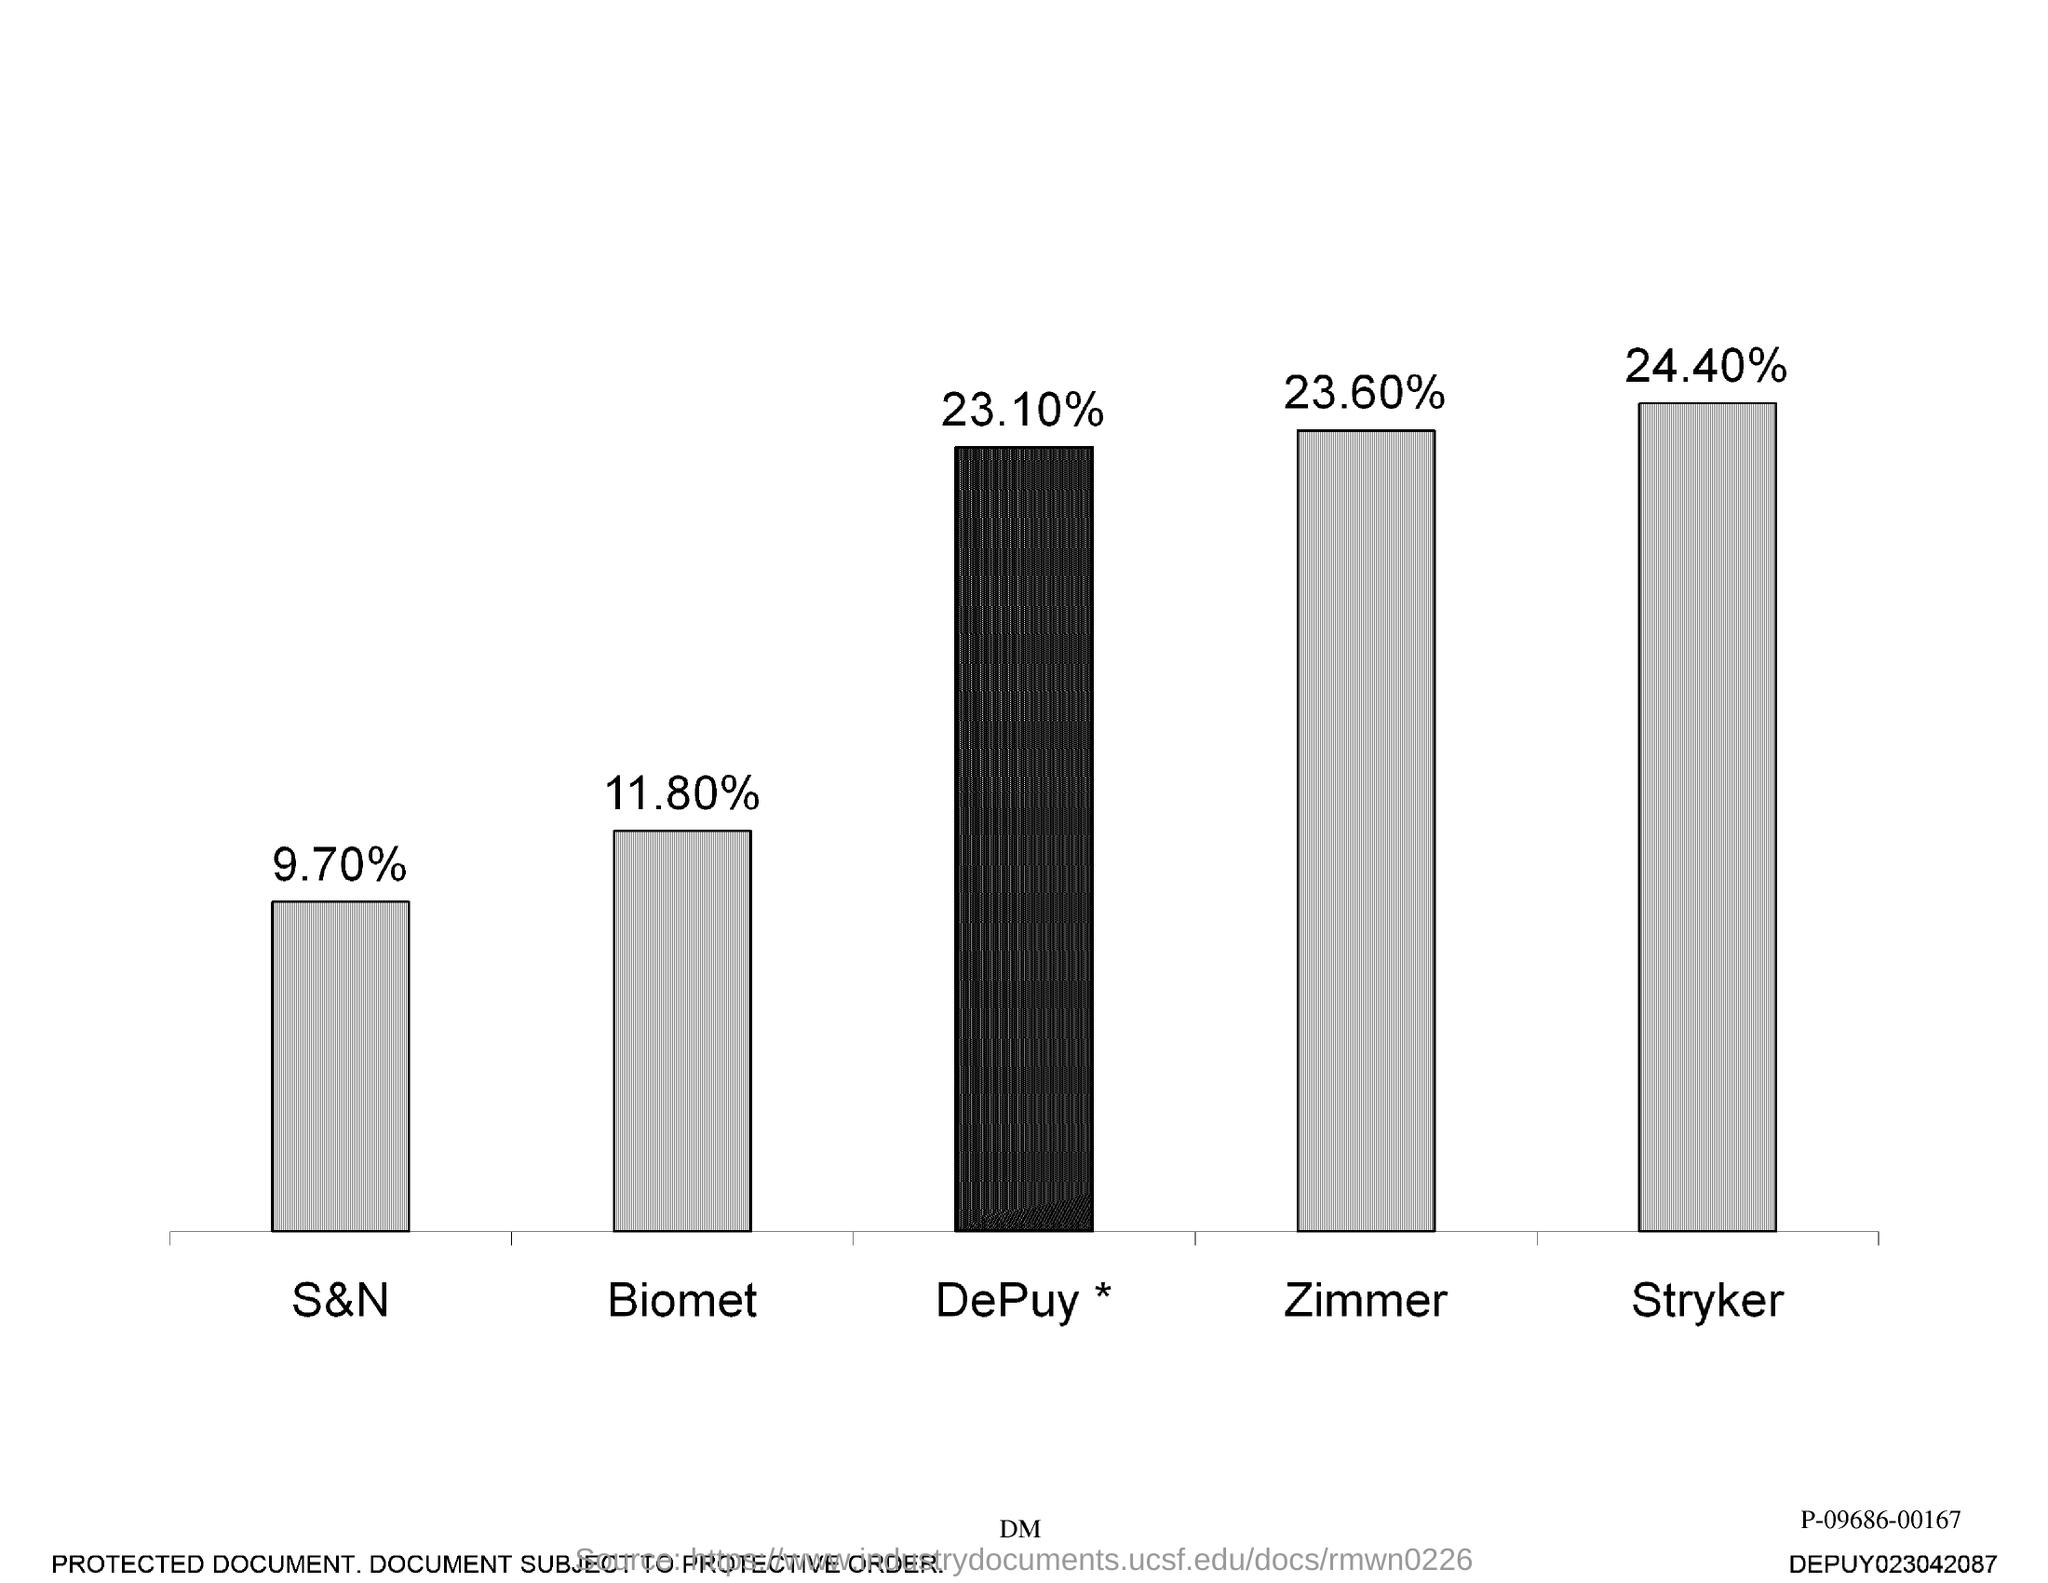Mention a couple of crucial points in this snapshot. Zimmer's percentage is 23.60%. The company with the lowest percentage is S&N. Ninety-seven percent of the sample was composed of S and N. The company with the highest percentage is Stryker. The percentage of Stryker is 24.40%. 